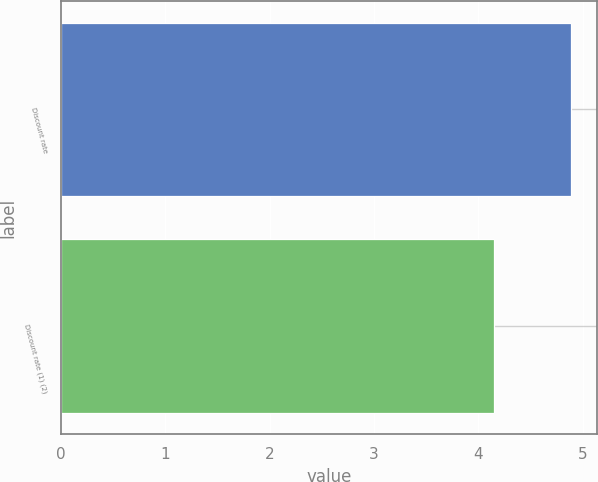Convert chart. <chart><loc_0><loc_0><loc_500><loc_500><bar_chart><fcel>Discount rate<fcel>Discount rate (1) (2)<nl><fcel>4.89<fcel>4.15<nl></chart> 